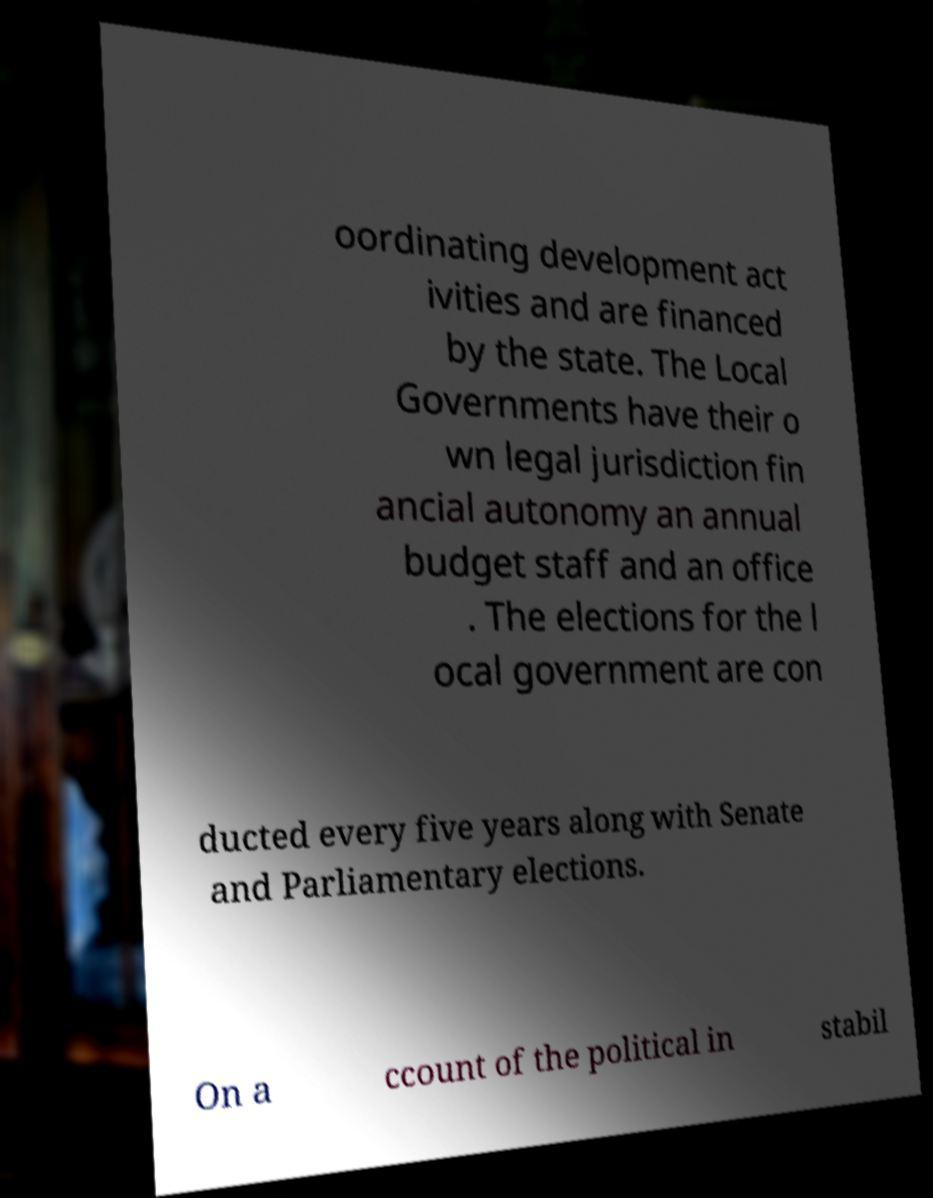Can you read and provide the text displayed in the image?This photo seems to have some interesting text. Can you extract and type it out for me? oordinating development act ivities and are financed by the state. The Local Governments have their o wn legal jurisdiction fin ancial autonomy an annual budget staff and an office . The elections for the l ocal government are con ducted every five years along with Senate and Parliamentary elections. On a ccount of the political in stabil 